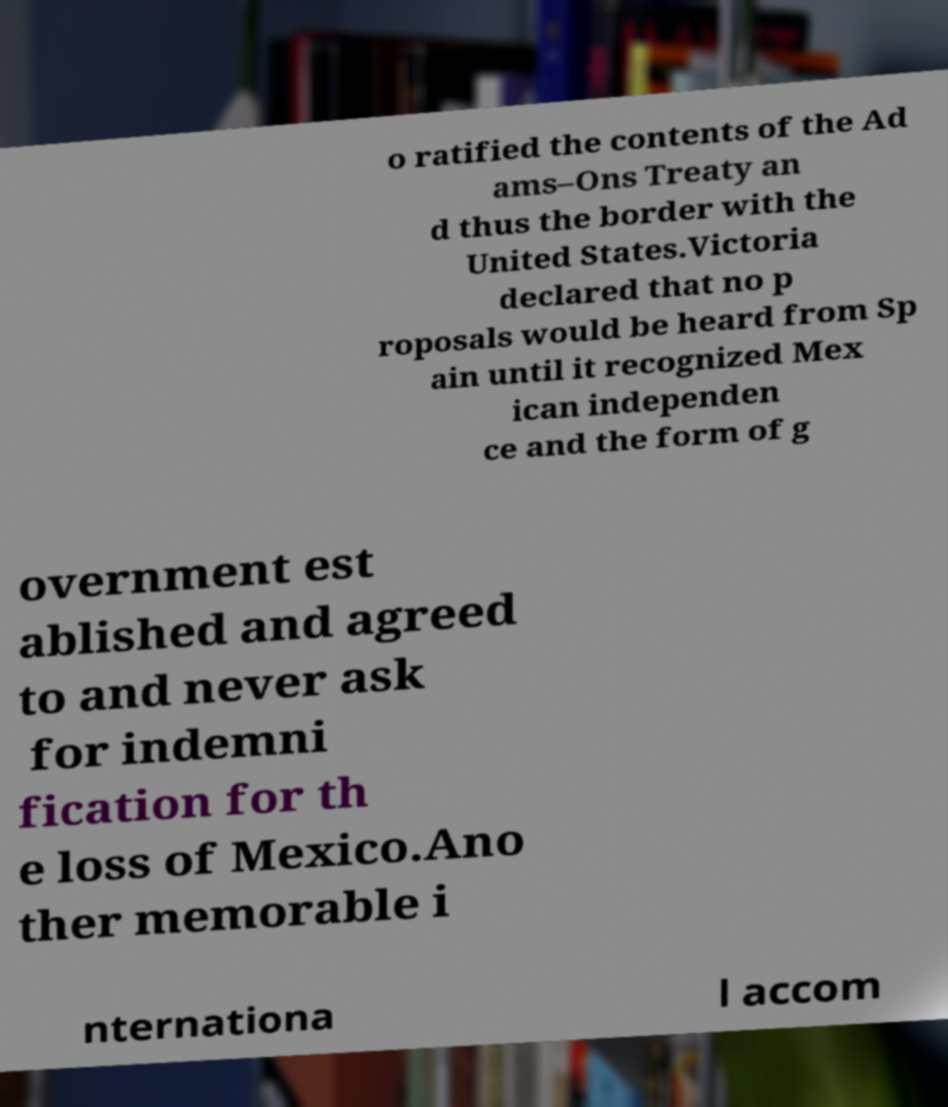Could you assist in decoding the text presented in this image and type it out clearly? o ratified the contents of the Ad ams–Ons Treaty an d thus the border with the United States.Victoria declared that no p roposals would be heard from Sp ain until it recognized Mex ican independen ce and the form of g overnment est ablished and agreed to and never ask for indemni fication for th e loss of Mexico.Ano ther memorable i nternationa l accom 